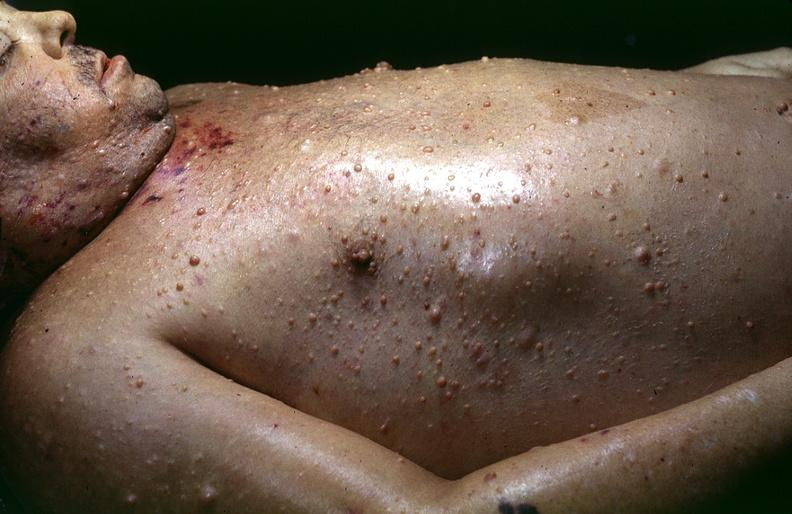does this image show skin, neurofibromatosis?
Answer the question using a single word or phrase. Yes 